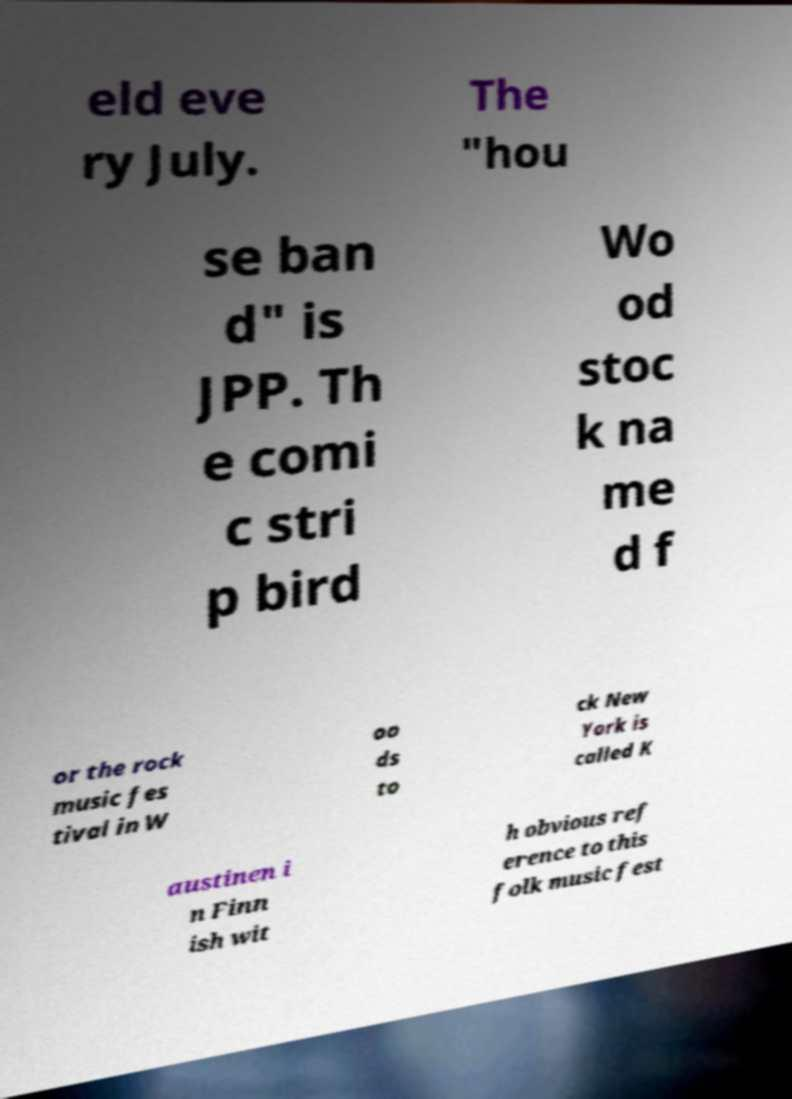Please read and relay the text visible in this image. What does it say? eld eve ry July. The "hou se ban d" is JPP. Th e comi c stri p bird Wo od stoc k na me d f or the rock music fes tival in W oo ds to ck New York is called K austinen i n Finn ish wit h obvious ref erence to this folk music fest 